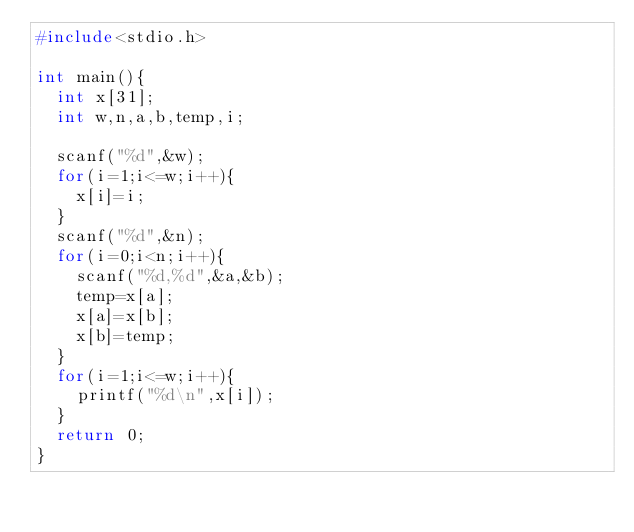<code> <loc_0><loc_0><loc_500><loc_500><_C_>#include<stdio.h>

int main(){
  int x[31];
  int w,n,a,b,temp,i;
  
  scanf("%d",&w);
  for(i=1;i<=w;i++){
    x[i]=i;
  }
  scanf("%d",&n);
  for(i=0;i<n;i++){
    scanf("%d,%d",&a,&b);
    temp=x[a];
    x[a]=x[b];
    x[b]=temp;
  }
  for(i=1;i<=w;i++){
    printf("%d\n",x[i]);
  }
  return 0;
}</code> 